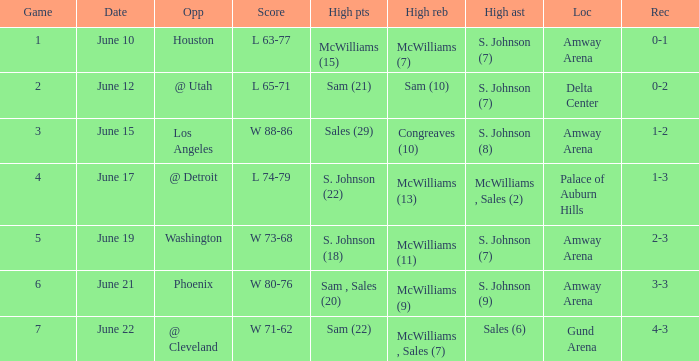Name the total number of date for  l 63-77 1.0. 